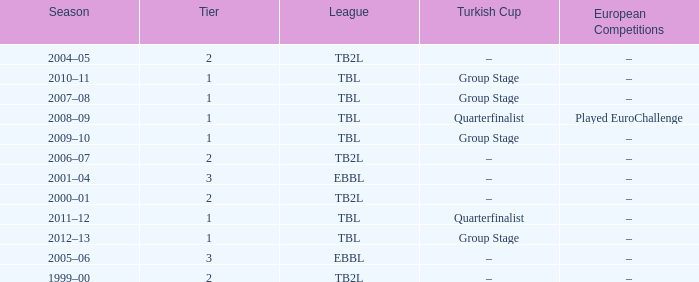Tier of 2, and a Season of 2004–05 is what European competitions? –. 